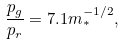<formula> <loc_0><loc_0><loc_500><loc_500>\frac { p _ { g } } { p _ { r } } = 7 . 1 m _ { * } ^ { - 1 / 2 } ,</formula> 